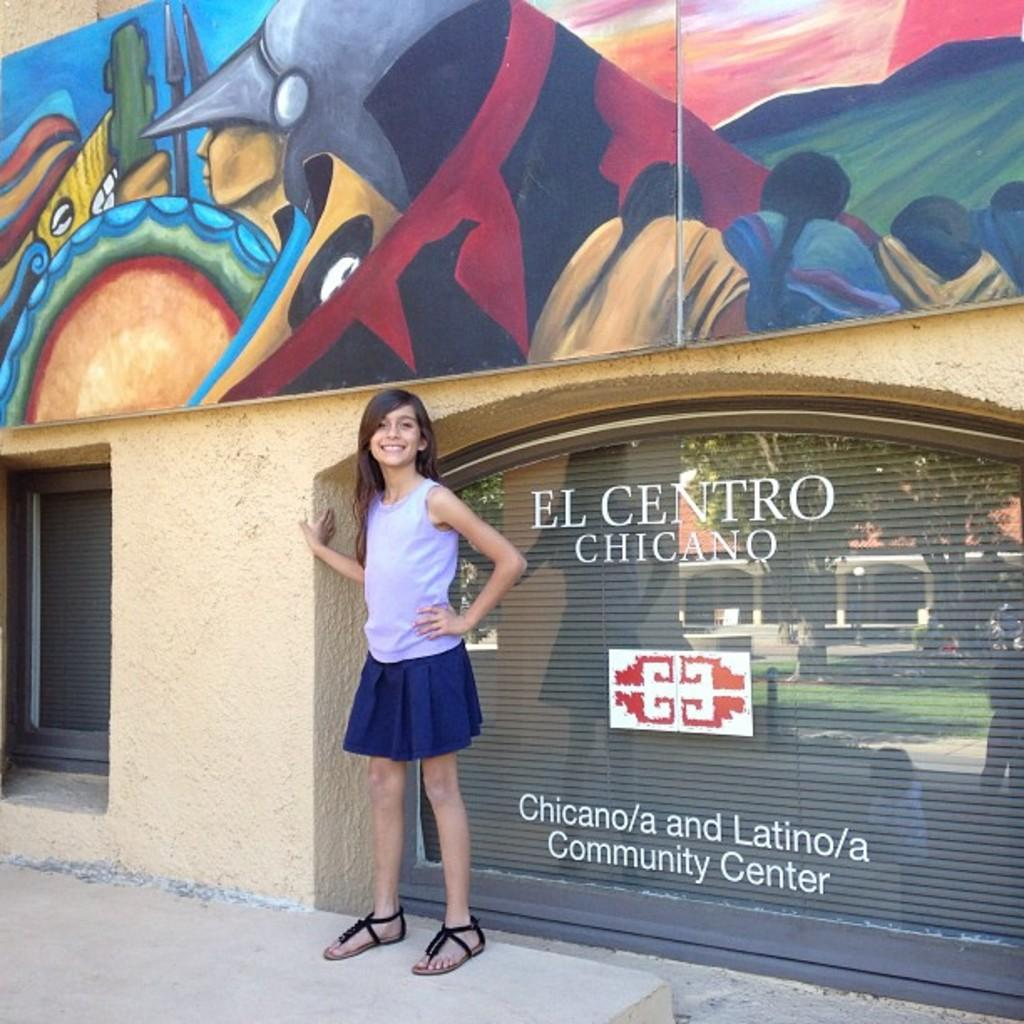<image>
Summarize the visual content of the image. A girl poses in front of the community center. 